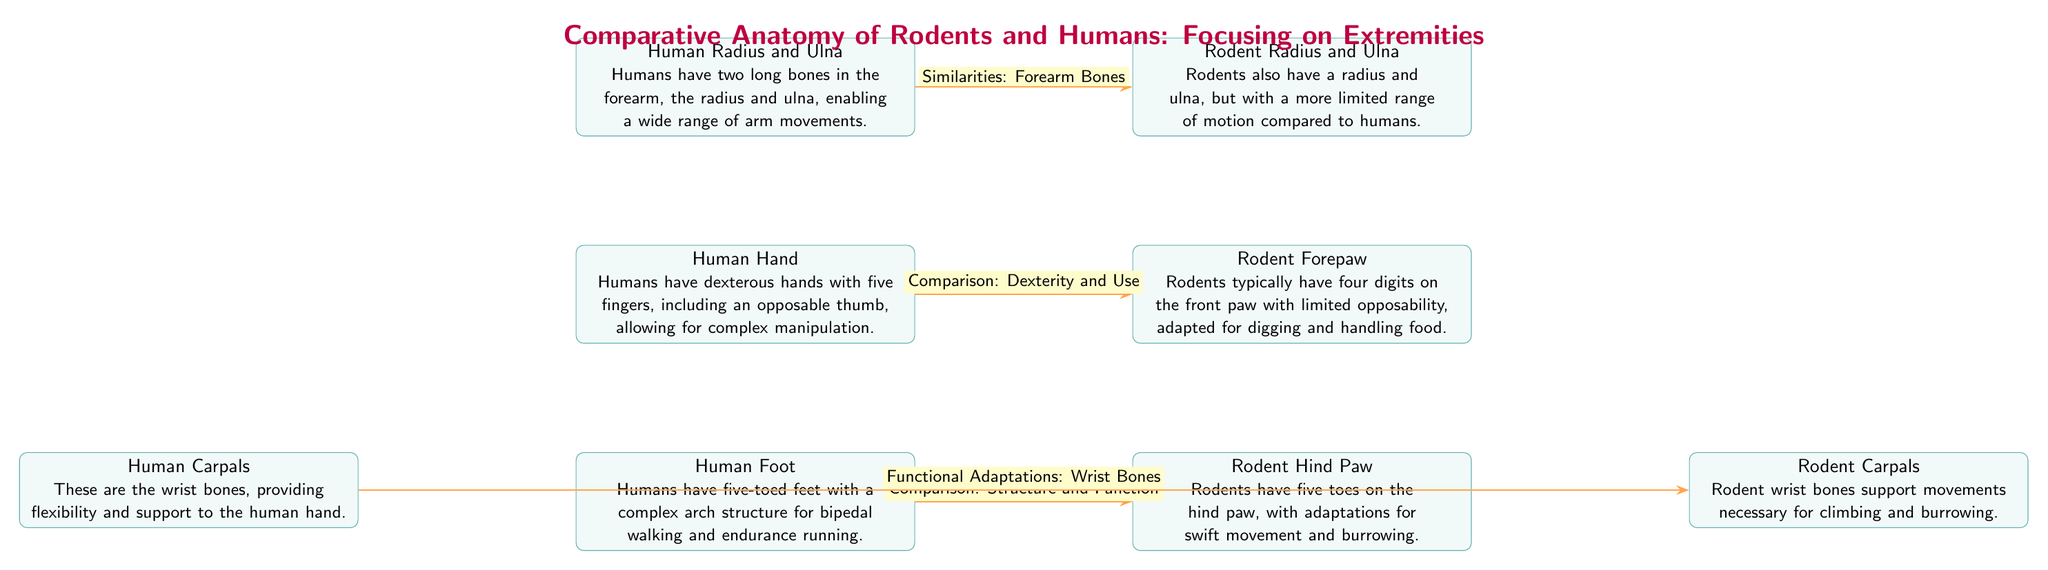What is the main focus of the diagram? The diagram is titled "Comparative Anatomy of Rodents and Humans: Focusing on Extremities," indicating that it primarily compares the anatomical features of the extremities (hands and feet) of rodents and humans.
Answer: Comparative Anatomy of Rodents and Humans: Focusing on Extremities How many digits are on a Rodent Forepaw? The node describing the Rodent Forepaw states that "Rodents typically have four digits on the front paw," providing direct information about the number of digits.
Answer: Four What type of movement adaptations does the Rodent Hind Paw have? The description of the Rodent Hind Paw mentions "adaptations for swift movement and burrowing," focusing on its functional characteristics related to movement.
Answer: Swift movement and burrowing What do humans possess that allows for complex manipulation? The Human Hand description states that "Humans have dexterous hands with five fingers, including an opposable thumb," indicating the unique feature that enables manipulation.
Answer: Opposable thumb Which bone pair provides flexibility to the human hand? The Human Carpals node specifically states that "These are the wrist bones, providing flexibility and support to the human hand," linking the carpals to flexibility.
Answer: Carpals What is the primary anatomical similarity between humans and rodents in the context of forelimbs? The edge connecting Human Radius and Ulna to Rodent Radius and Ulna indicates "Similarities: Forearm Bones," detailing the commonality in forelimb structure.
Answer: Radius and Ulna How are the wrist bones of rodents adapted? The description of Rodent Carpals states that "Rodent wrist bones support movements necessary for climbing and burrowing," highlighting their specific adaptations.
Answer: Climbing and burrowing What unique feature do human feet have for locomotion? The Human Foot node states that "Humans have five-toed feet with a complex arch structure for bipedal walking," indicating the specific feature supporting their locomotion.
Answer: Complex arch structure How many nodes represent the human extremities in this diagram? The diagram includes two nodes that specifically represent human extremities: Human Hand and Human Foot, indicating there are two relevant nodes.
Answer: Two 